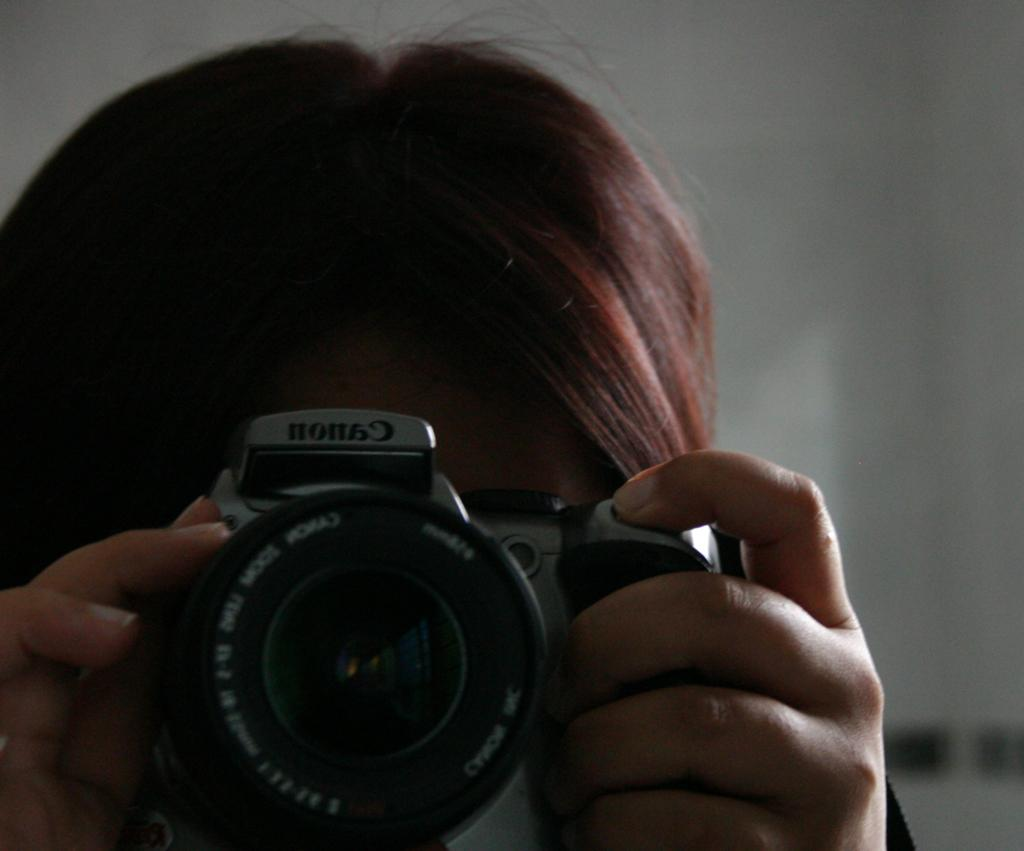Who is the main subject in the image? There is a person in the image. What is the person holding in the image? The person is holding a camera. What is the person doing with the camera? The person is clicking a picture. What can be seen in the background of the image? There is a wall in the background of the image. What word is being spelled out by the airplane in the image? There is no airplane present in the image, so no word can be spelled out by an airplane. 